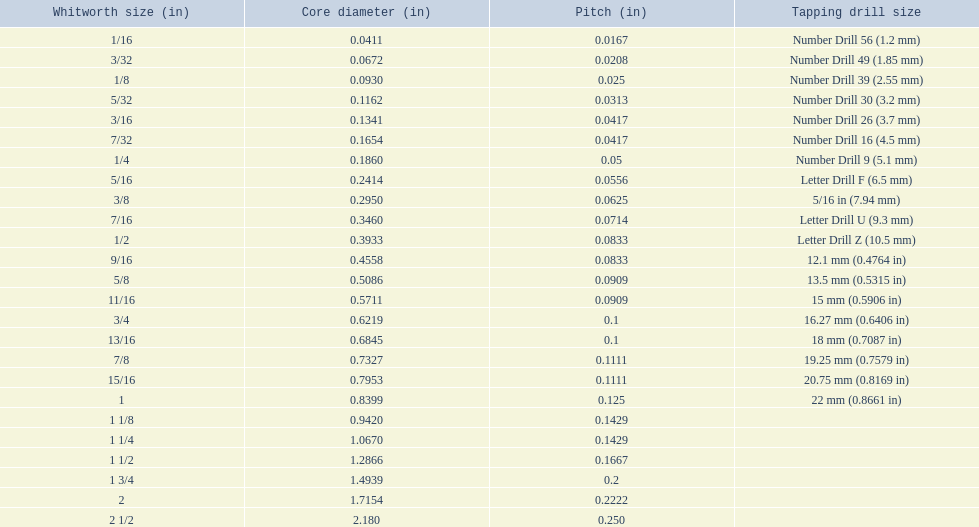What are the sizes of threads per inch? 60, 48, 40, 32, 24, 24, 20, 18, 16, 14, 12, 12, 11, 11, 10, 10, 9, 9, 8, 7, 7, 6, 5, 4.5, 4. Which whitworth size has only 5 threads per inch? 1 3/4. 